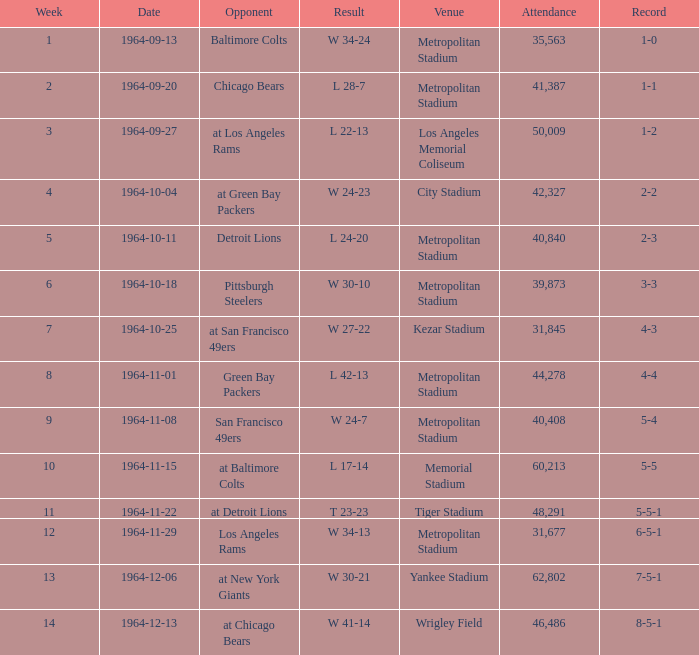What is the outcome when the record was 1-0 and it was prior to week 4? W 34-24. 